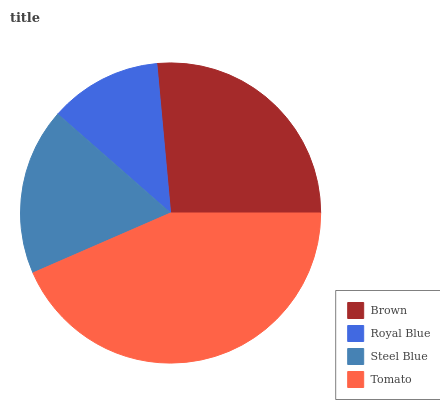Is Royal Blue the minimum?
Answer yes or no. Yes. Is Tomato the maximum?
Answer yes or no. Yes. Is Steel Blue the minimum?
Answer yes or no. No. Is Steel Blue the maximum?
Answer yes or no. No. Is Steel Blue greater than Royal Blue?
Answer yes or no. Yes. Is Royal Blue less than Steel Blue?
Answer yes or no. Yes. Is Royal Blue greater than Steel Blue?
Answer yes or no. No. Is Steel Blue less than Royal Blue?
Answer yes or no. No. Is Brown the high median?
Answer yes or no. Yes. Is Steel Blue the low median?
Answer yes or no. Yes. Is Steel Blue the high median?
Answer yes or no. No. Is Brown the low median?
Answer yes or no. No. 